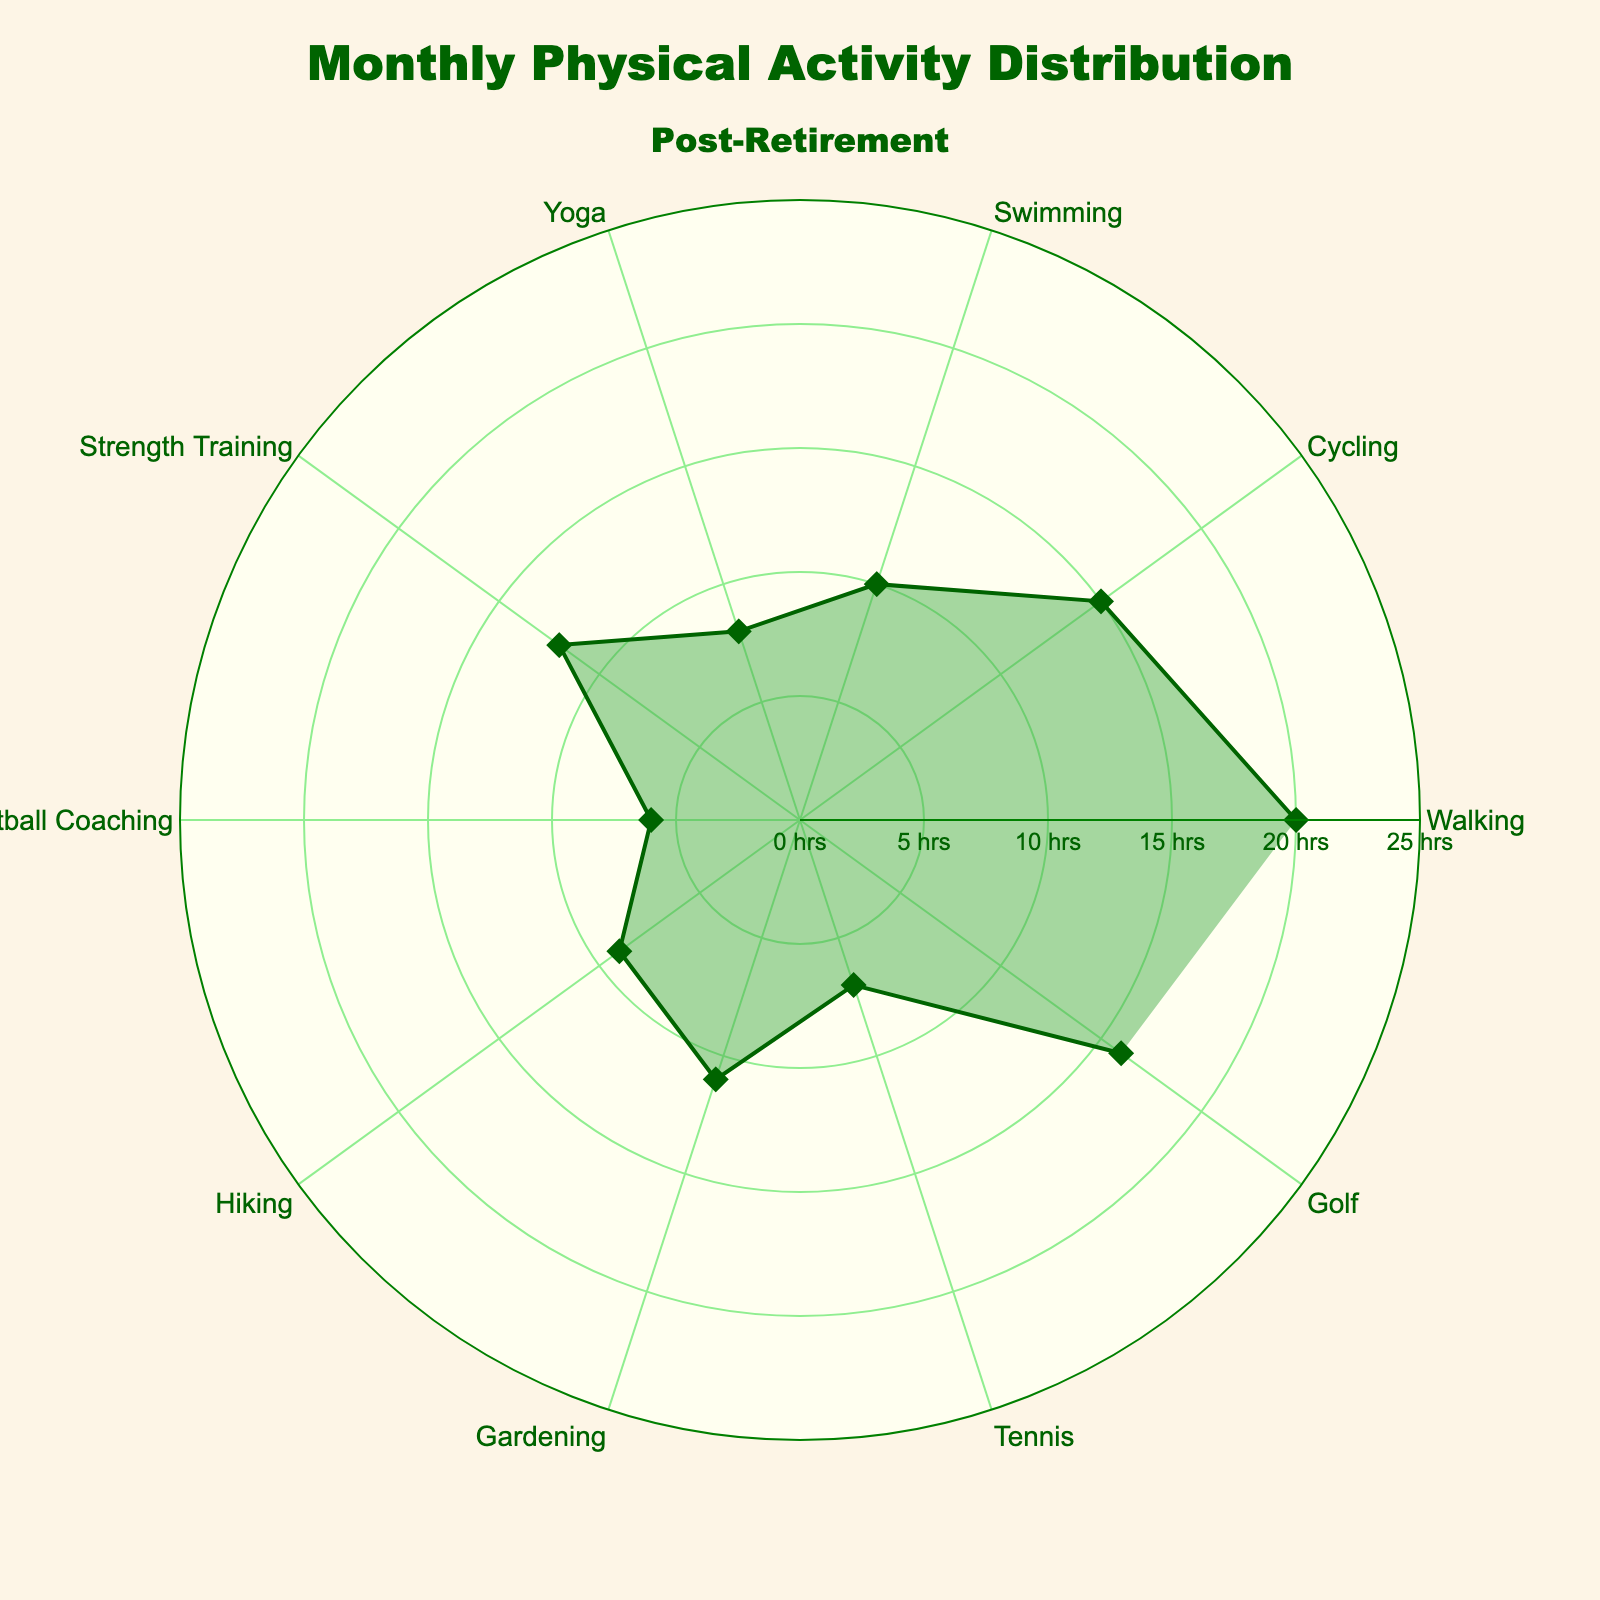Which activity has the highest number of hours? The figure shows various activities with their hours represented on the polar chart. The longest bar stretches to 20 hours for Walking.
Answer: Walking How many activities have fewer than 10 hours? Observing the radial lengths for each activity, those with fewer than 10 hours are Swimming (10), Yoga (8), Football Coaching (6), Tennis (7), and Hiking (9), making a total of 5 such activities.
Answer: 5 What is the average number of hours spent on all activities? Sum of hours: 20 + 15 + 10 + 8 + 12 + 6 + 9 + 11 + 7 + 16 = 114. There are 10 activities. The average is 114/10 = 11.4
Answer: 11.4 Which activity has more hours, Gardening or Tennis? Gardening has 11 hours, while Tennis has 7 hours. Gardening has more hours than Tennis.
Answer: Gardening How many hours more is spent on Golf compared to Yoga? Golf has 16 hours, and Yoga has 8 hours. The difference is 16 - 8 = 8 hours.
Answer: 8 Which activities have between 10 and 15 hours? Cycling has 15 hours, Strength Training has 12 hours, Gardening has 11 hours, and Swimming has 10 hours.
Answer: Cycling, Strength Training, Gardening, Swimming What is the total amount of time spent on both Football Coaching and Strength Training? Football Coaching has 6 hours, and Strength Training has 12 hours. Combining them gives 6 + 12 = 18 hours.
Answer: 18 Which activity has fewer hours, Swimming or Hiking? Swimming has 10 hours, and Hiking has 9 hours. Hiking has fewer hours.
Answer: Hiking What is the median number of hours spent on these activities? Listing hours in ascending order: 6, 7, 8, 9, 10, 11, 12, 15, 16, 20. The median is the average of the 5th and 6th items: (10 + 11) / 2 = 10.5.
Answer: 10.5 What is the total amount of hours spent walking, swimming, and hiking combined? Walking has 20 hours, Swimming has 10 hours, and Hiking has 9 hours. Summing them gives 20 + 10 + 9 = 39 hours.
Answer: 39 